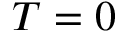<formula> <loc_0><loc_0><loc_500><loc_500>T = 0</formula> 